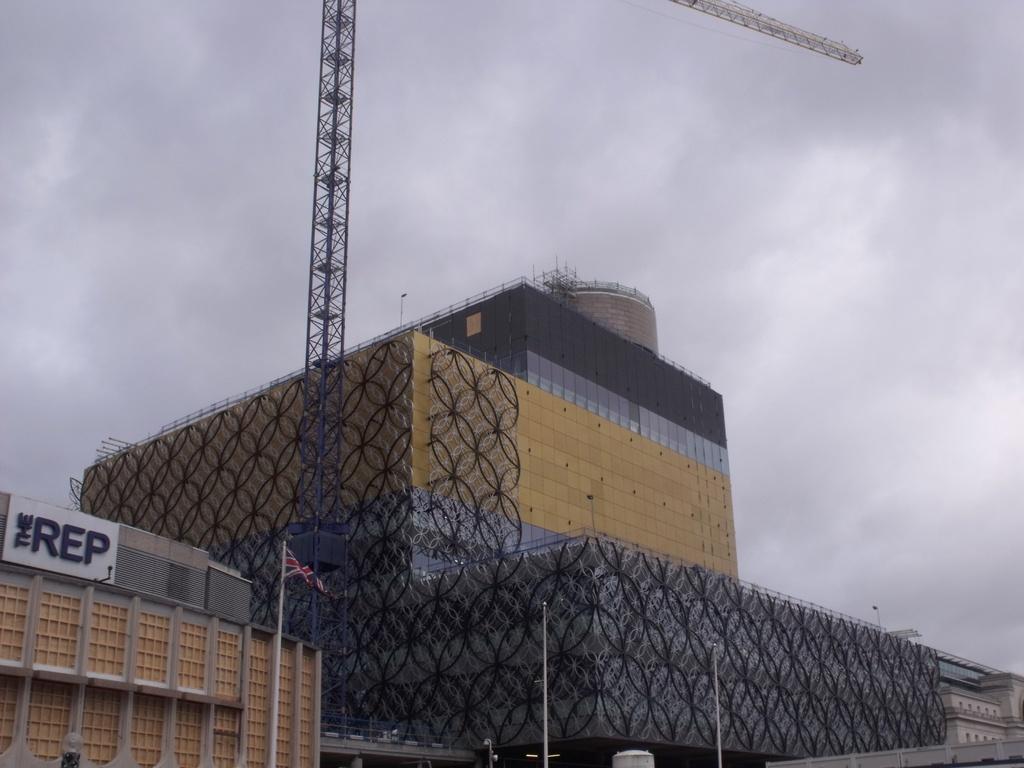Could you give a brief overview of what you see in this image? In the picture I can see buildings, a board which has something written on it, a flag, poles and some other objects. In the background I can see the sky. 